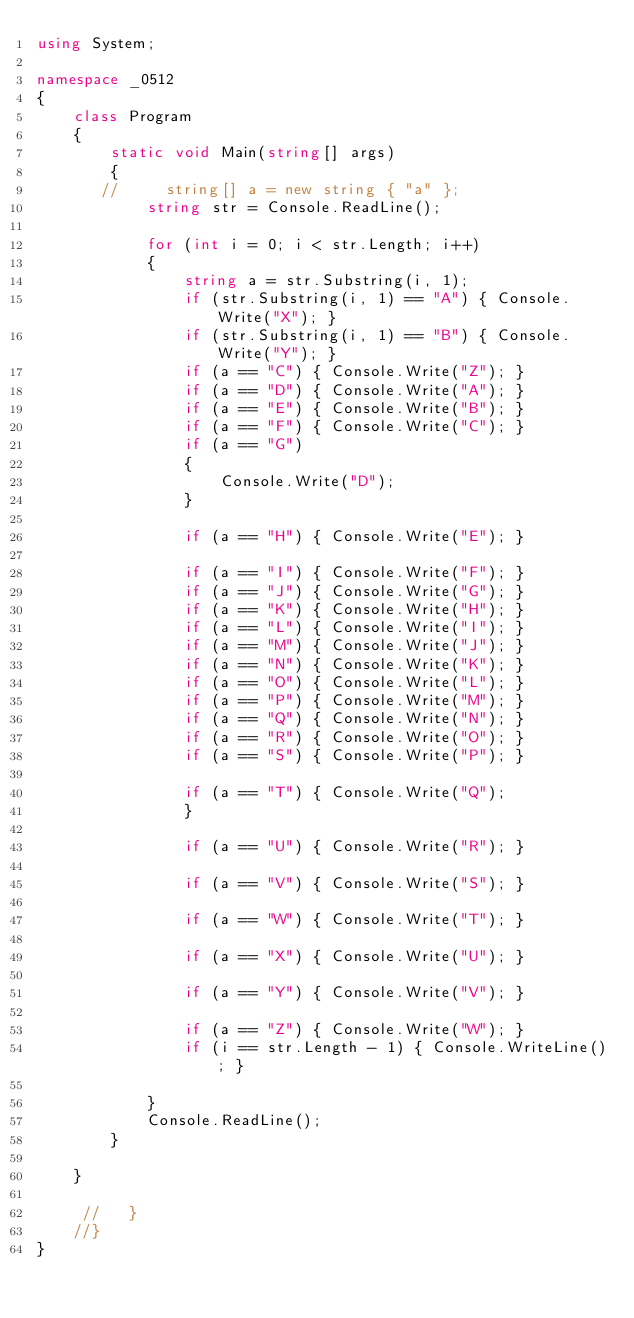<code> <loc_0><loc_0><loc_500><loc_500><_C#_>using System;

namespace _0512
{
    class Program
    {
        static void Main(string[] args)
        {
       //     string[] a = new string { "a" };
            string str = Console.ReadLine();

            for (int i = 0; i < str.Length; i++)
            {
                string a = str.Substring(i, 1);
                if (str.Substring(i, 1) == "A") { Console.Write("X"); }
                if (str.Substring(i, 1) == "B") { Console.Write("Y"); }
                if (a == "C") { Console.Write("Z"); }
                if (a == "D") { Console.Write("A"); }
                if (a == "E") { Console.Write("B"); }
                if (a == "F") { Console.Write("C"); }
                if (a == "G")
                {
                    Console.Write("D");
                }

                if (a == "H") { Console.Write("E"); }

                if (a == "I") { Console.Write("F"); }
                if (a == "J") { Console.Write("G"); }
                if (a == "K") { Console.Write("H"); }
                if (a == "L") { Console.Write("I"); }
                if (a == "M") { Console.Write("J"); }
                if (a == "N") { Console.Write("K"); }
                if (a == "O") { Console.Write("L"); }
                if (a == "P") { Console.Write("M"); }
                if (a == "Q") { Console.Write("N"); }
                if (a == "R") { Console.Write("O"); }
                if (a == "S") { Console.Write("P"); }

                if (a == "T") { Console.Write("Q");
                }

                if (a == "U") { Console.Write("R"); }

                if (a == "V") { Console.Write("S"); }

                if (a == "W") { Console.Write("T"); }

                if (a == "X") { Console.Write("U"); }

                if (a == "Y") { Console.Write("V"); }

                if (a == "Z") { Console.Write("W"); }
                if (i == str.Length - 1) { Console.WriteLine(); }

            }
            Console.ReadLine();
        }

    }
        
     //   }
    //}
}</code> 